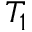Convert formula to latex. <formula><loc_0><loc_0><loc_500><loc_500>T _ { 1 }</formula> 